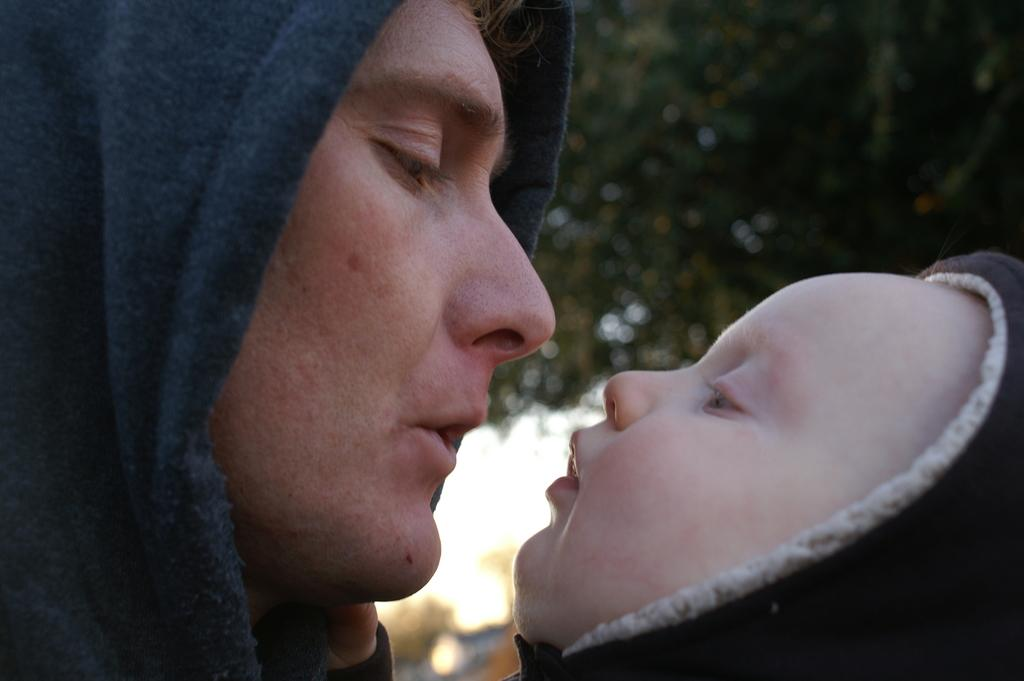Who is present in the image? There is a man and a baby in the image. What can be seen in the background of the image? There are trees in the background of the image. What type of fruit is being cared for by the man in the image? There is no fruit present in the image, and the man is not shown caring for any fruit. What type of land can be seen in the image? The image does not provide information about the type of land; it only shows a man, a baby, and trees in the background. 